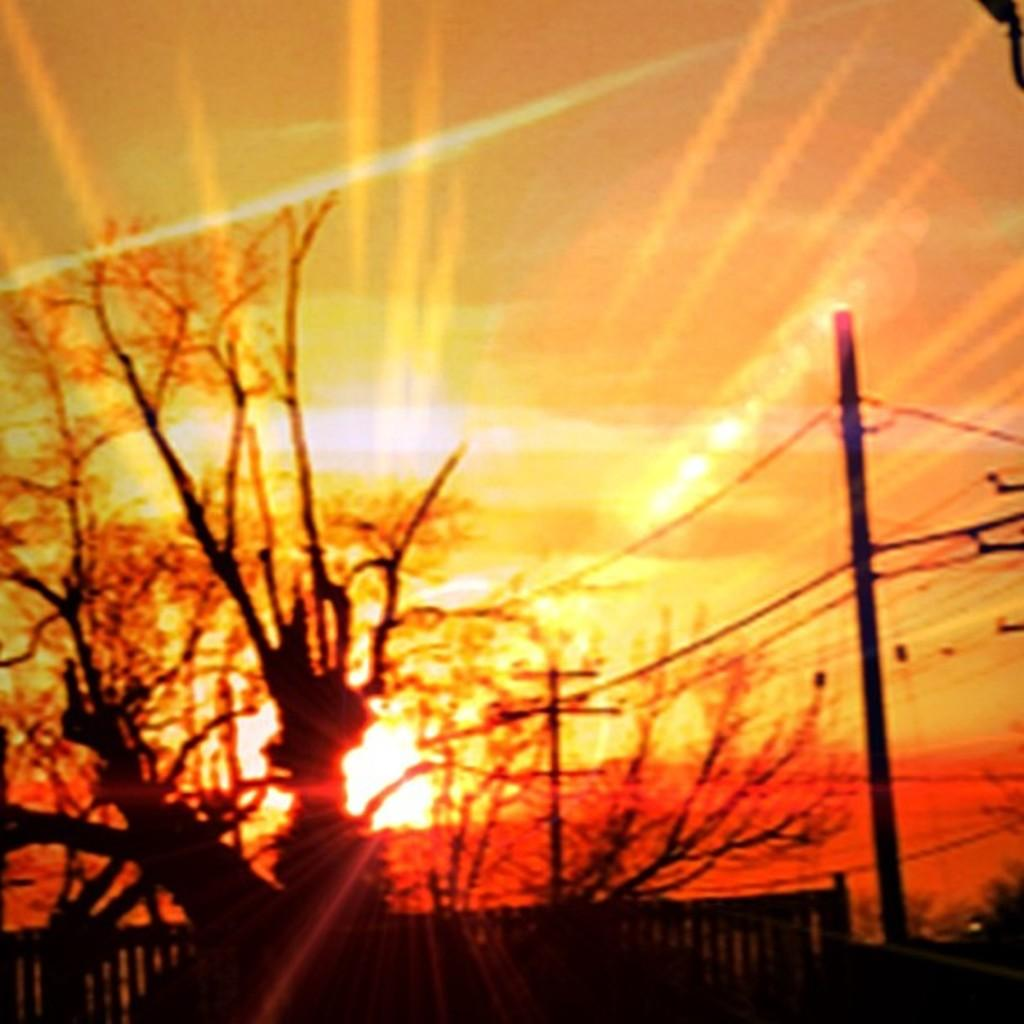What is located in the center of the image? There are trees in the center of the image. What type of structure can be seen in the image? There is an electric light pole in the image. What is connected to the light pole? Wires are present in the image. What type of barrier is visible in the image? There is fencing in the image. What can be observed in the sky in the image? The top of the image depicts a sunset. What type of berry is growing on the trees in the image? There is no mention of berries in the image; the trees are not described as having any fruit or berries. What discovery was made at the location depicted in the image? There is no indication of a discovery being made in the image; it simply shows trees, a light pole, wires, fencing, and a sunset. 